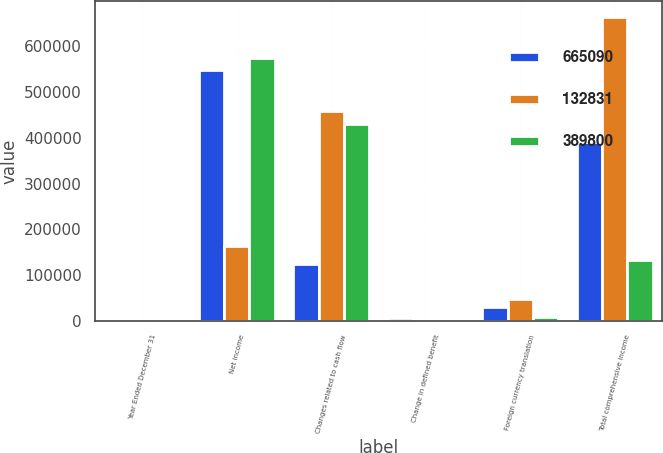Convert chart. <chart><loc_0><loc_0><loc_500><loc_500><stacked_bar_chart><ecel><fcel>Year Ended December 31<fcel>Net income<fcel>Changes related to cash flow<fcel>Change in defined benefit<fcel>Foreign currency translation<fcel>Total comprehensive income<nl><fcel>665090<fcel>2010<fcel>547467<fcel>123180<fcel>5422<fcel>29065<fcel>389800<nl><fcel>132831<fcel>2009<fcel>162421<fcel>458220<fcel>2562<fcel>47011<fcel>665090<nl><fcel>389800<fcel>2008<fcel>573722<fcel>430051<fcel>2835<fcel>8005<fcel>132831<nl></chart> 